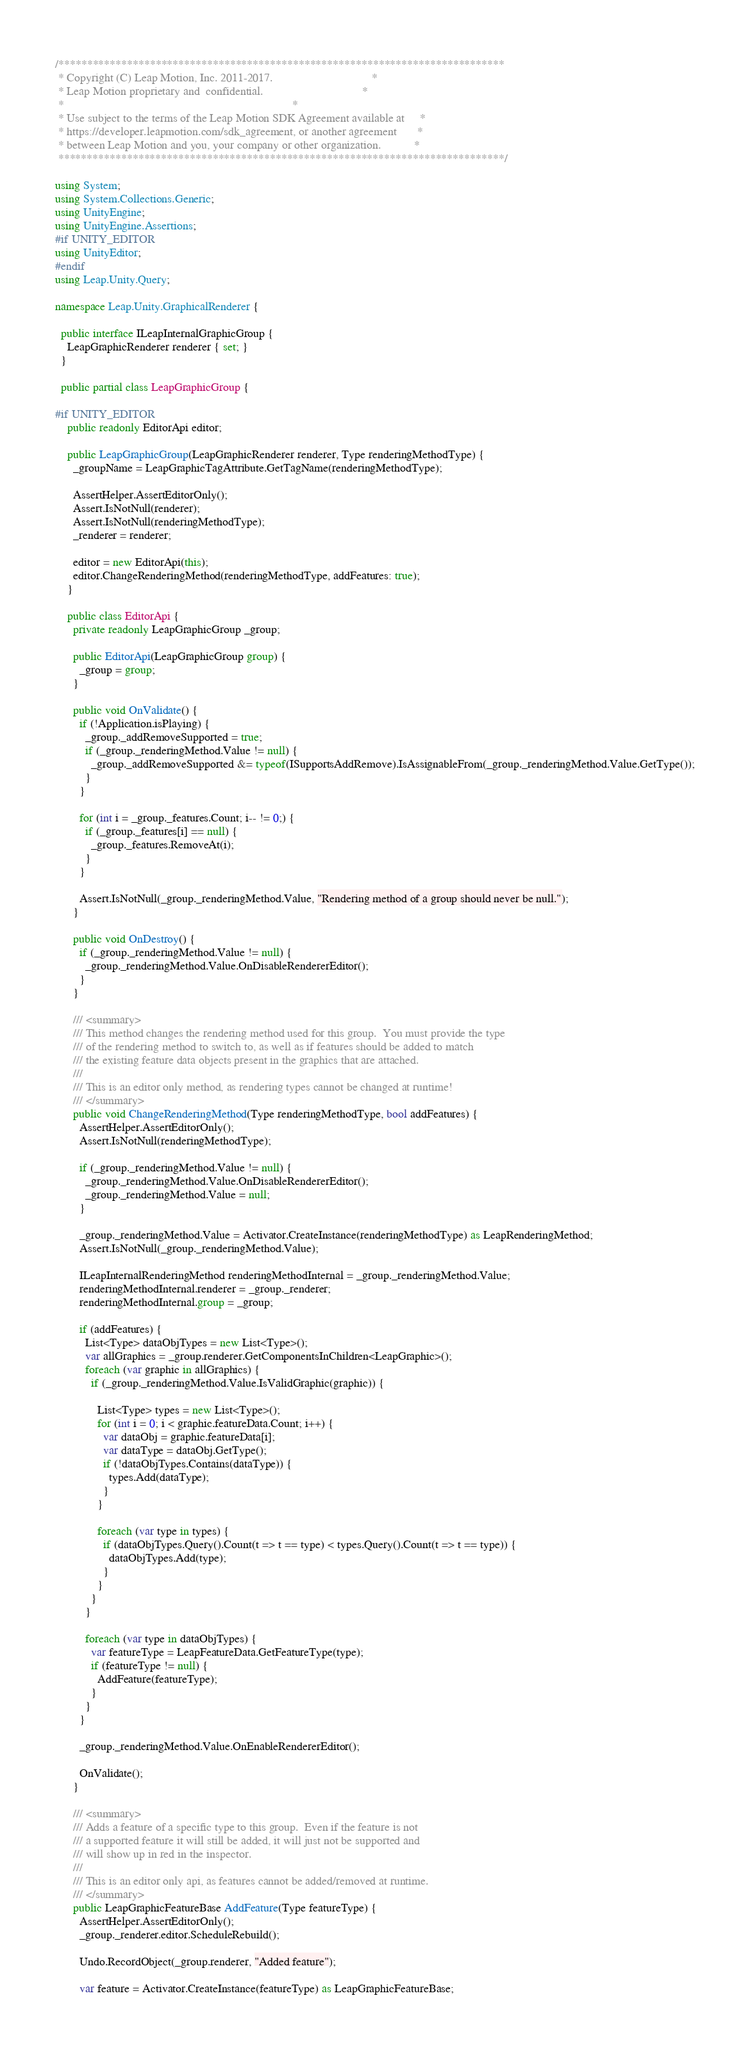Convert code to text. <code><loc_0><loc_0><loc_500><loc_500><_C#_>/******************************************************************************
 * Copyright (C) Leap Motion, Inc. 2011-2017.                                 *
 * Leap Motion proprietary and  confidential.                                 *
 *                                                                            *
 * Use subject to the terms of the Leap Motion SDK Agreement available at     *
 * https://developer.leapmotion.com/sdk_agreement, or another agreement       *
 * between Leap Motion and you, your company or other organization.           *
 ******************************************************************************/

using System;
using System.Collections.Generic;
using UnityEngine;
using UnityEngine.Assertions;
#if UNITY_EDITOR
using UnityEditor;
#endif
using Leap.Unity.Query;

namespace Leap.Unity.GraphicalRenderer {

  public interface ILeapInternalGraphicGroup {
    LeapGraphicRenderer renderer { set; }
  }

  public partial class LeapGraphicGroup {

#if UNITY_EDITOR
    public readonly EditorApi editor;

    public LeapGraphicGroup(LeapGraphicRenderer renderer, Type renderingMethodType) {
      _groupName = LeapGraphicTagAttribute.GetTagName(renderingMethodType);

      AssertHelper.AssertEditorOnly();
      Assert.IsNotNull(renderer);
      Assert.IsNotNull(renderingMethodType);
      _renderer = renderer;

      editor = new EditorApi(this);
      editor.ChangeRenderingMethod(renderingMethodType, addFeatures: true);
    }

    public class EditorApi {
      private readonly LeapGraphicGroup _group;

      public EditorApi(LeapGraphicGroup group) {
        _group = group;
      }

      public void OnValidate() {
        if (!Application.isPlaying) {
          _group._addRemoveSupported = true;
          if (_group._renderingMethod.Value != null) {
            _group._addRemoveSupported &= typeof(ISupportsAddRemove).IsAssignableFrom(_group._renderingMethod.Value.GetType());
          }
        }

        for (int i = _group._features.Count; i-- != 0;) {
          if (_group._features[i] == null) {
            _group._features.RemoveAt(i);
          }
        }

        Assert.IsNotNull(_group._renderingMethod.Value, "Rendering method of a group should never be null.");
      }

      public void OnDestroy() {
        if (_group._renderingMethod.Value != null) {
          _group._renderingMethod.Value.OnDisableRendererEditor();
        }
      }

      /// <summary>
      /// This method changes the rendering method used for this group.  You must provide the type
      /// of the rendering method to switch to, as well as if features should be added to match
      /// the existing feature data objects present in the graphics that are attached.
      ///
      /// This is an editor only method, as rendering types cannot be changed at runtime!
      /// </summary>
      public void ChangeRenderingMethod(Type renderingMethodType, bool addFeatures) {
        AssertHelper.AssertEditorOnly();
        Assert.IsNotNull(renderingMethodType);

        if (_group._renderingMethod.Value != null) {
          _group._renderingMethod.Value.OnDisableRendererEditor();
          _group._renderingMethod.Value = null;
        }

        _group._renderingMethod.Value = Activator.CreateInstance(renderingMethodType) as LeapRenderingMethod;
        Assert.IsNotNull(_group._renderingMethod.Value);

        ILeapInternalRenderingMethod renderingMethodInternal = _group._renderingMethod.Value;
        renderingMethodInternal.renderer = _group._renderer;
        renderingMethodInternal.group = _group;

        if (addFeatures) {
          List<Type> dataObjTypes = new List<Type>();
          var allGraphics = _group.renderer.GetComponentsInChildren<LeapGraphic>();
          foreach (var graphic in allGraphics) {
            if (_group._renderingMethod.Value.IsValidGraphic(graphic)) {

              List<Type> types = new List<Type>();
              for (int i = 0; i < graphic.featureData.Count; i++) {
                var dataObj = graphic.featureData[i];
                var dataType = dataObj.GetType();
                if (!dataObjTypes.Contains(dataType)) {
                  types.Add(dataType);
                }
              }

              foreach (var type in types) {
                if (dataObjTypes.Query().Count(t => t == type) < types.Query().Count(t => t == type)) {
                  dataObjTypes.Add(type);
                }
              }
            }
          }

          foreach (var type in dataObjTypes) {
            var featureType = LeapFeatureData.GetFeatureType(type);
            if (featureType != null) {
              AddFeature(featureType);
            }
          }
        }

        _group._renderingMethod.Value.OnEnableRendererEditor();

        OnValidate();
      }

      /// <summary>
      /// Adds a feature of a specific type to this group.  Even if the feature is not
      /// a supported feature it will still be added, it will just not be supported and
      /// will show up in red in the inspector.
      ///
      /// This is an editor only api, as features cannot be added/removed at runtime.
      /// </summary>
      public LeapGraphicFeatureBase AddFeature(Type featureType) {
        AssertHelper.AssertEditorOnly();
        _group._renderer.editor.ScheduleRebuild();

        Undo.RecordObject(_group.renderer, "Added feature");

        var feature = Activator.CreateInstance(featureType) as LeapGraphicFeatureBase;</code> 